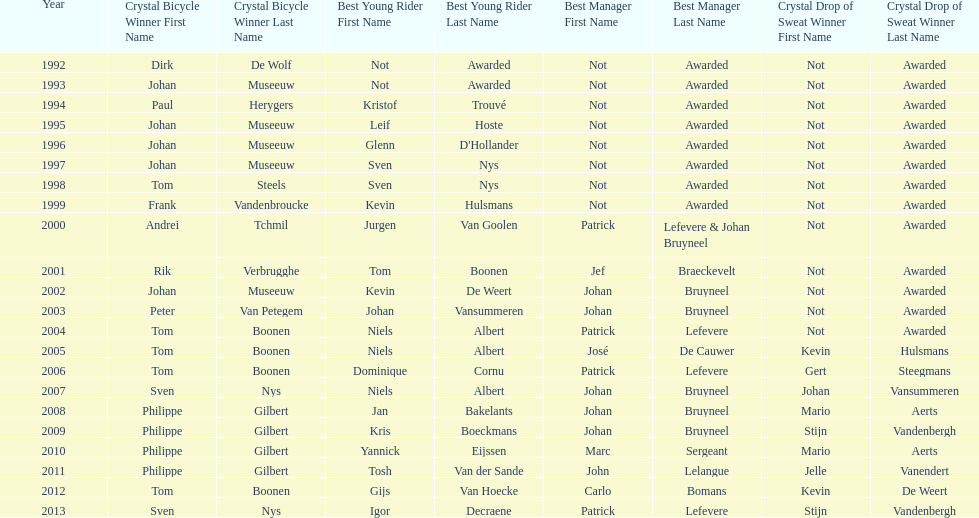Who has won the most best young rider awards? Niels Albert. 